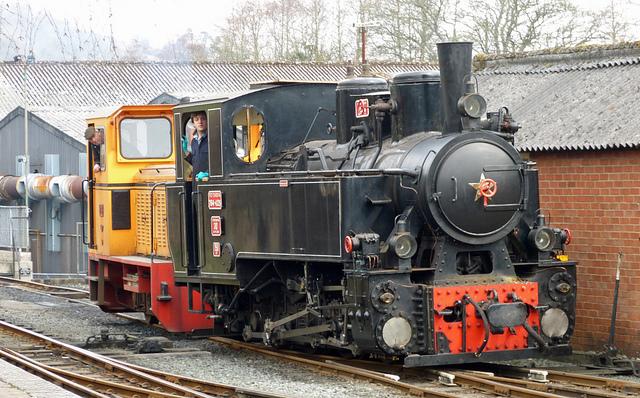Are the roofs shown made at an angle to discourage bird-nesting?
Keep it brief. Yes. What type of train is this?
Write a very short answer. Locomotive. How many people are in this photo?
Short answer required. 1. 